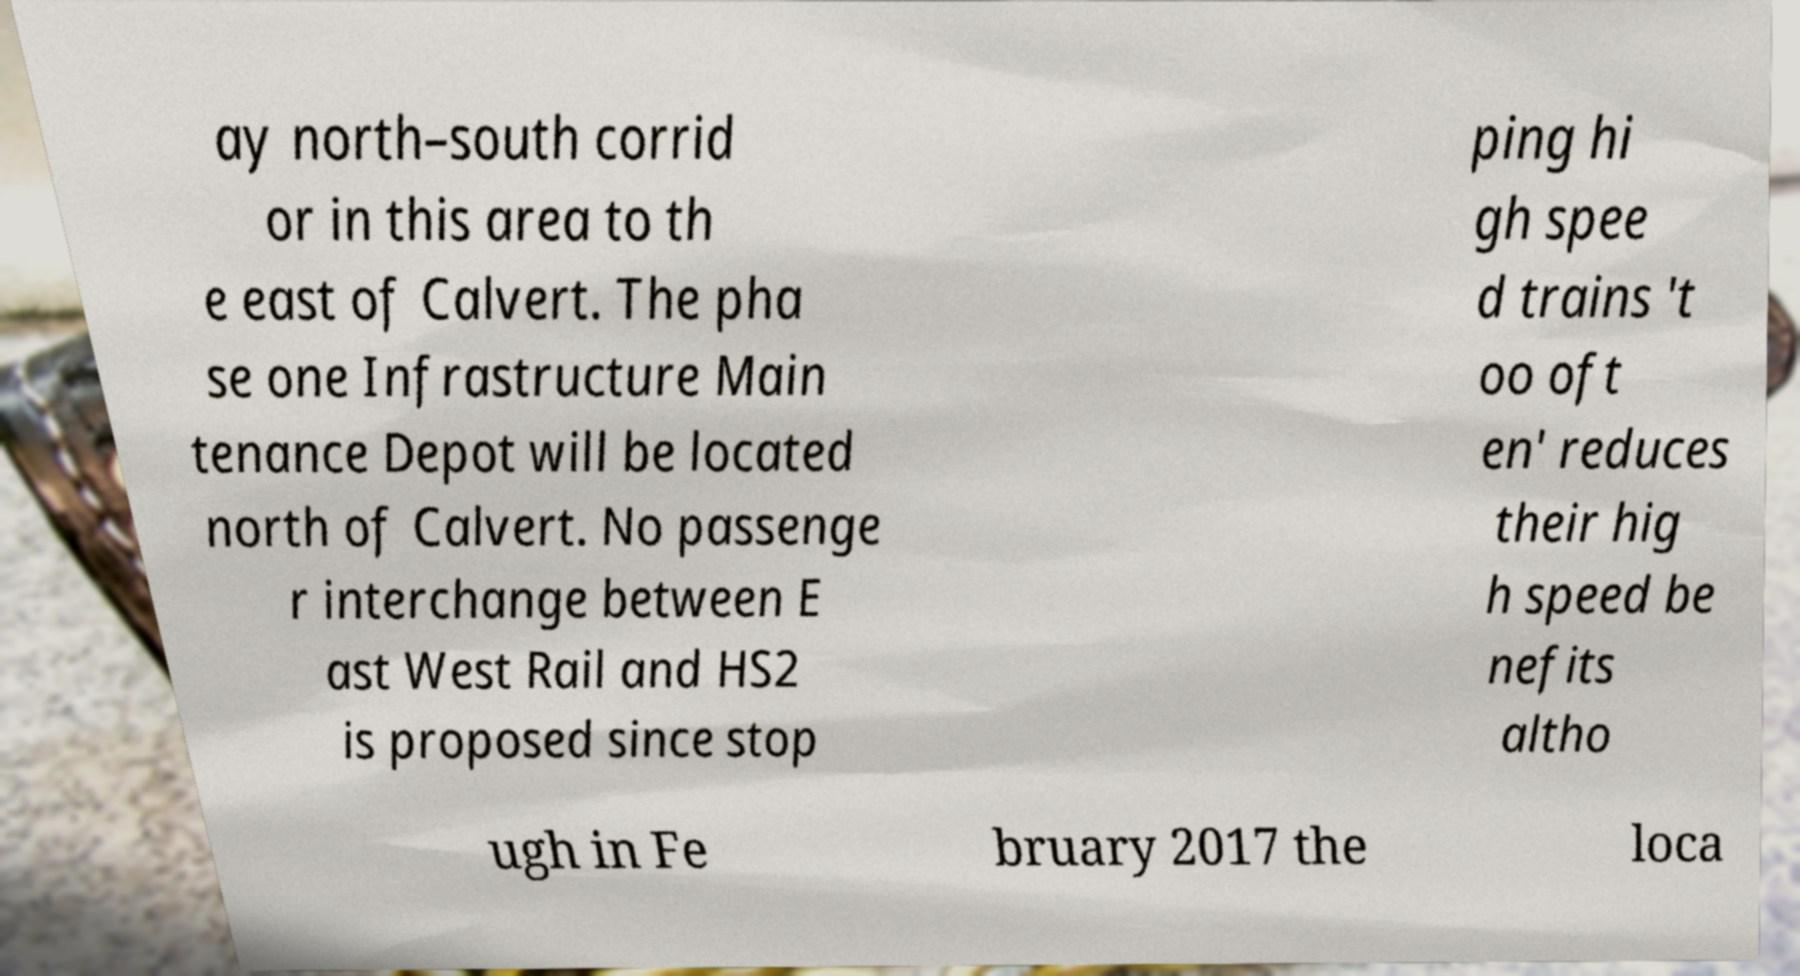For documentation purposes, I need the text within this image transcribed. Could you provide that? ay north–south corrid or in this area to th e east of Calvert. The pha se one Infrastructure Main tenance Depot will be located north of Calvert. No passenge r interchange between E ast West Rail and HS2 is proposed since stop ping hi gh spee d trains 't oo oft en' reduces their hig h speed be nefits altho ugh in Fe bruary 2017 the loca 